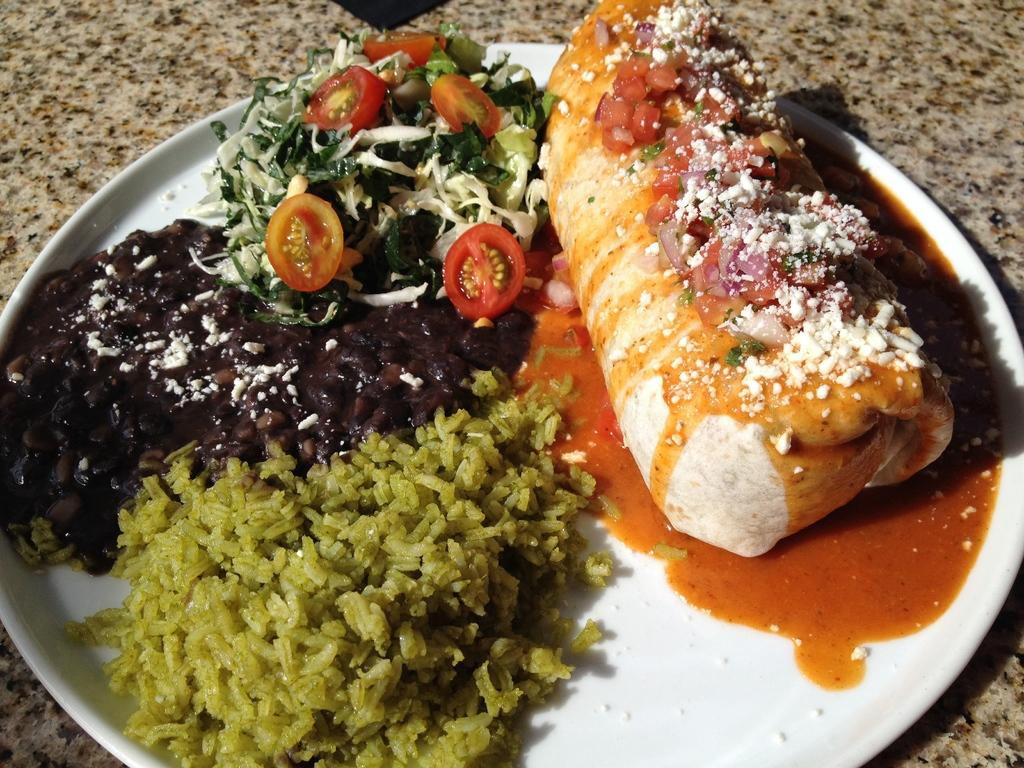What is on the plate in the image? There are food items on a plate in the image. What color is the plate? The plate is white. Where is the plate located in the image? The plate is placed on a surface. What type of sheet is covering the food on the plate? There is no sheet covering the food on the plate in the image. What kind of growth can be seen on the surface where the plate is placed? There is no growth visible on the surface where the plate is placed in the image. 